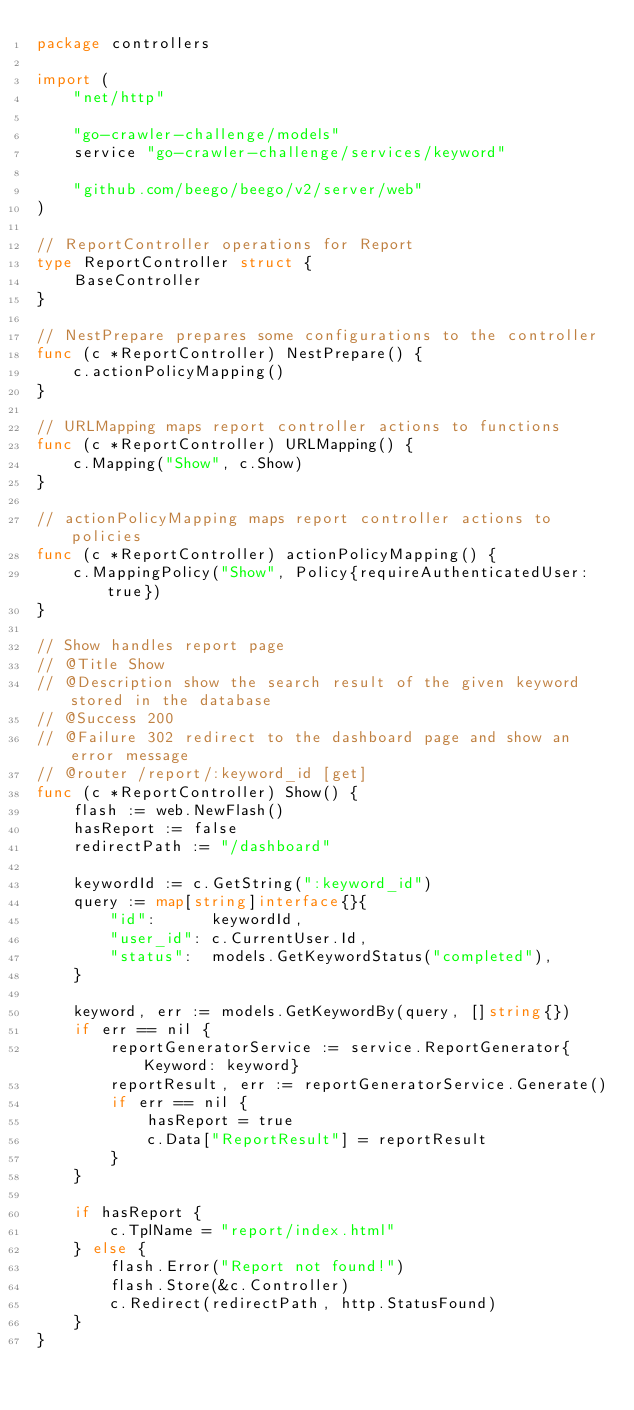<code> <loc_0><loc_0><loc_500><loc_500><_Go_>package controllers

import (
	"net/http"

	"go-crawler-challenge/models"
	service "go-crawler-challenge/services/keyword"

	"github.com/beego/beego/v2/server/web"
)

// ReportController operations for Report
type ReportController struct {
	BaseController
}

// NestPrepare prepares some configurations to the controller
func (c *ReportController) NestPrepare() {
	c.actionPolicyMapping()
}

// URLMapping maps report controller actions to functions
func (c *ReportController) URLMapping() {
	c.Mapping("Show", c.Show)
}

// actionPolicyMapping maps report controller actions to policies
func (c *ReportController) actionPolicyMapping() {
	c.MappingPolicy("Show", Policy{requireAuthenticatedUser: true})
}

// Show handles report page
// @Title Show
// @Description show the search result of the given keyword stored in the database
// @Success 200
// @Failure 302 redirect to the dashboard page and show an error message
// @router /report/:keyword_id [get]
func (c *ReportController) Show() {
	flash := web.NewFlash()
	hasReport := false
	redirectPath := "/dashboard"

	keywordId := c.GetString(":keyword_id")
	query := map[string]interface{}{
		"id":      keywordId,
		"user_id": c.CurrentUser.Id,
		"status":  models.GetKeywordStatus("completed"),
	}

	keyword, err := models.GetKeywordBy(query, []string{})
	if err == nil {
		reportGeneratorService := service.ReportGenerator{Keyword: keyword}
		reportResult, err := reportGeneratorService.Generate()
		if err == nil {
			hasReport = true
			c.Data["ReportResult"] = reportResult
		}
	}

	if hasReport {
		c.TplName = "report/index.html"
	} else {
		flash.Error("Report not found!")
		flash.Store(&c.Controller)
		c.Redirect(redirectPath, http.StatusFound)
	}
}
</code> 